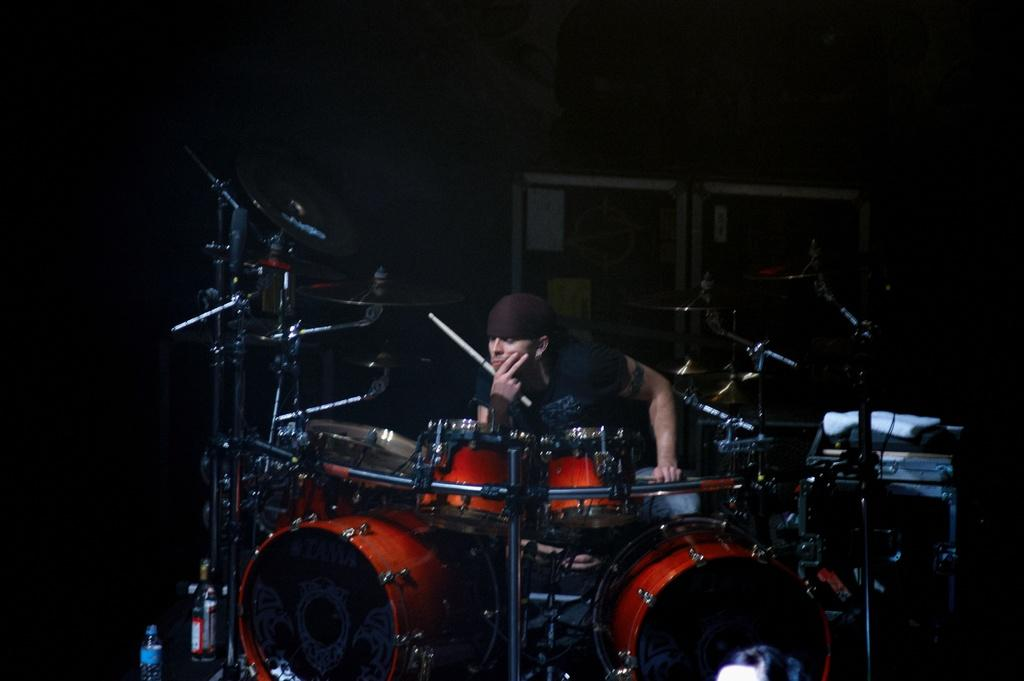What is the main subject of the image? There is a person sitting on a chair in the image. What is the person doing in the image? The person is surrounded by musical instruments. What can be seen in the background of the image? There are information boards in the background of the image. What type of drug is the person taking in the image? There is no indication in the image that the person is taking any drug, so it cannot be determined from the picture. 